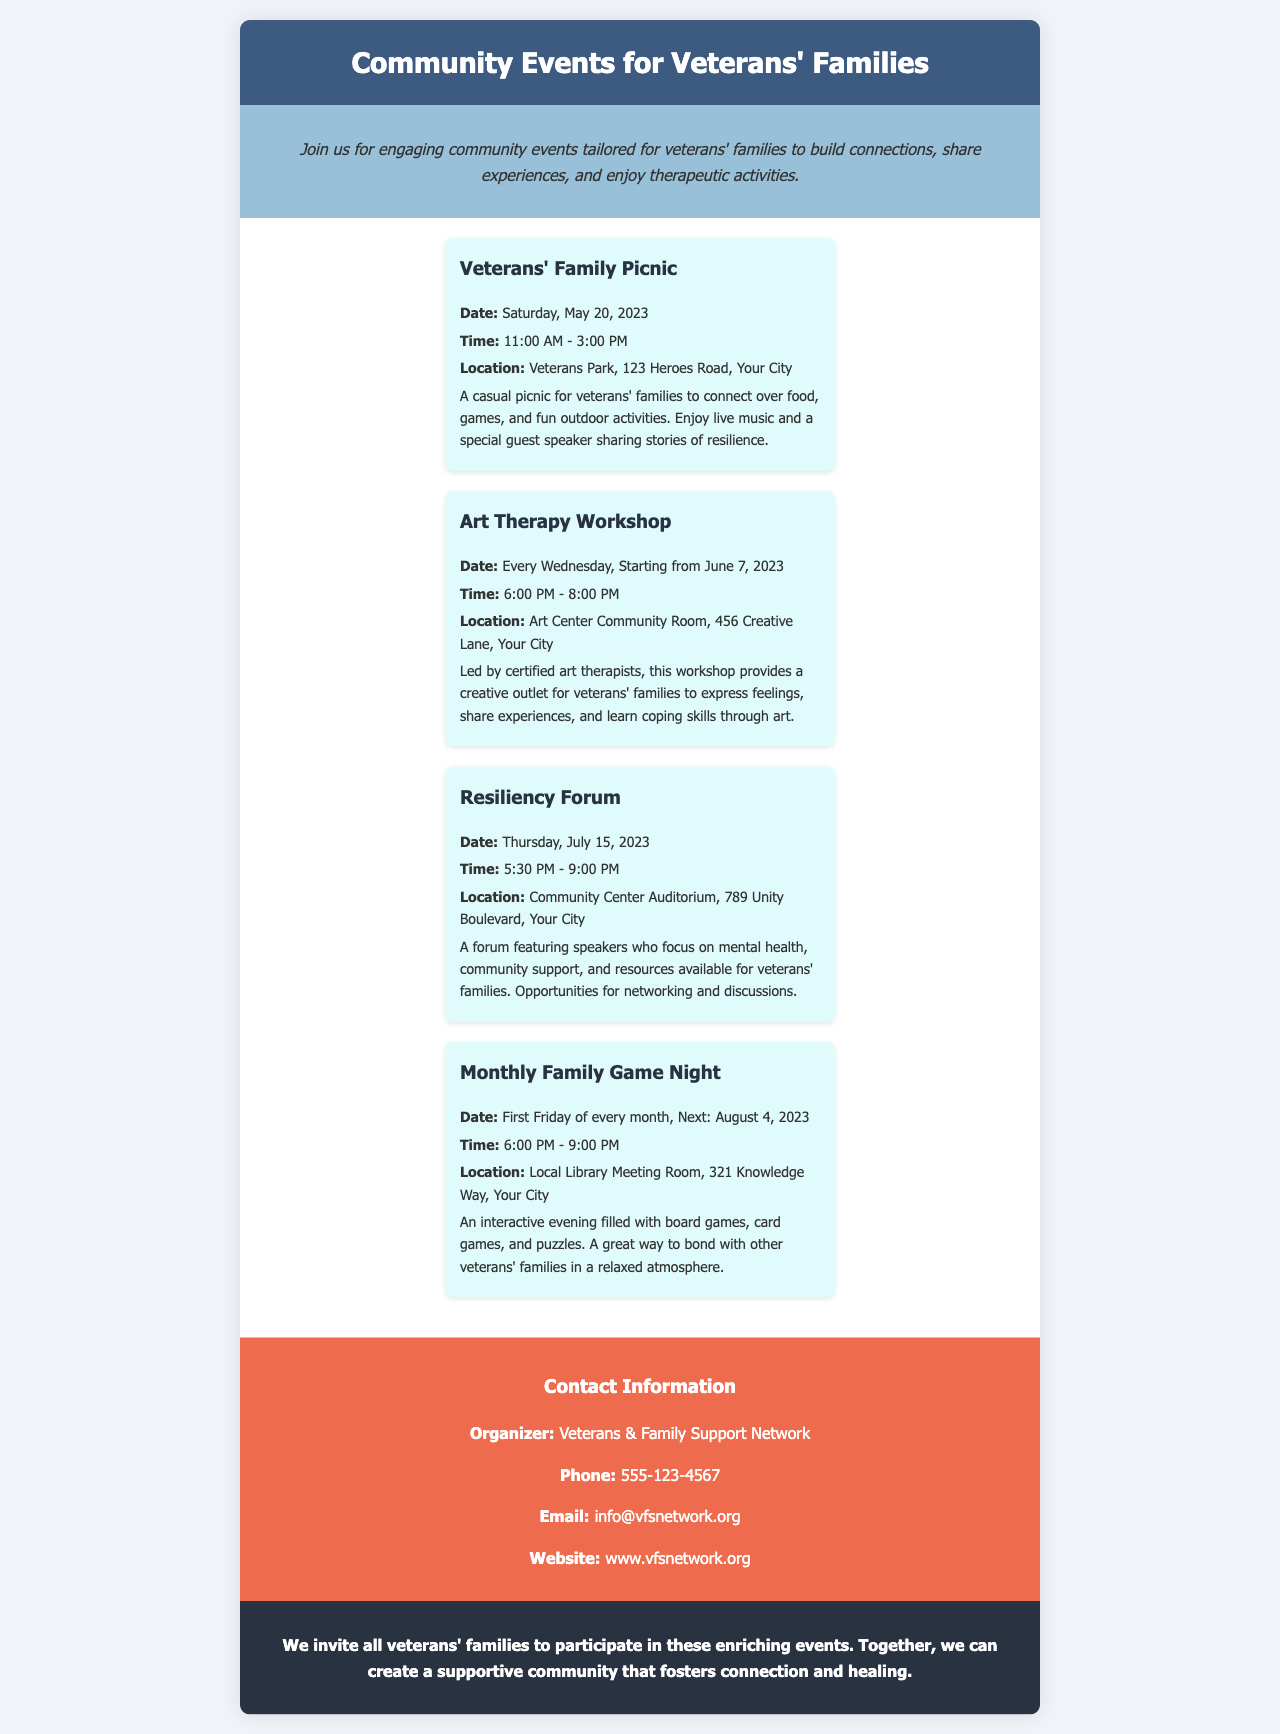What is the title of the brochure? The title is found in the header of the document, indicating the main theme of the content provided.
Answer: Community Events for Veterans' Families What is the date of the Veterans' Family Picnic? The picnic date is explicitly mentioned in the details of the event paragraph.
Answer: Saturday, May 20, 2023 What time does the Art Therapy Workshop start? The start time is listed in the event details section for the Art Therapy Workshop.
Answer: 6:00 PM Where is the Resiliency Forum taking place? The location is specified in the event description for the Resiliency Forum within the brochure.
Answer: Community Center Auditorium, 789 Unity Boulevard, Your City How often is the Monthly Family Game Night held? This information is detailed in the event description for the Monthly Family Game Night, outlining its regular occurrence.
Answer: First Friday of every month What kind of activities can families expect at the Veterans' Family Picnic? The event description highlights the types of activities that will take place during the picnic.
Answer: Food, games, and fun outdoor activities What is the purpose of the Art Therapy Workshop? The purpose is stated clearly in the event's description, focusing on the benefits of the workshop.
Answer: A creative outlet for veterans' families to express feelings Who is the organizer of these community events? The organizer's name is mentioned in the contact information section of the document.
Answer: Veterans & Family Support Network What is the website for more information? The website for additional details is provided in the contact section of the brochure.
Answer: www.vfsnetwork.org 